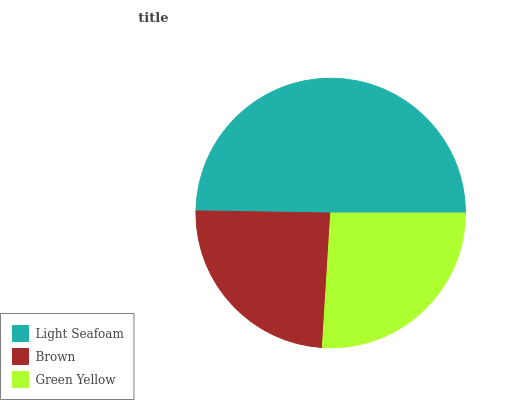Is Brown the minimum?
Answer yes or no. Yes. Is Light Seafoam the maximum?
Answer yes or no. Yes. Is Green Yellow the minimum?
Answer yes or no. No. Is Green Yellow the maximum?
Answer yes or no. No. Is Green Yellow greater than Brown?
Answer yes or no. Yes. Is Brown less than Green Yellow?
Answer yes or no. Yes. Is Brown greater than Green Yellow?
Answer yes or no. No. Is Green Yellow less than Brown?
Answer yes or no. No. Is Green Yellow the high median?
Answer yes or no. Yes. Is Green Yellow the low median?
Answer yes or no. Yes. Is Light Seafoam the high median?
Answer yes or no. No. Is Light Seafoam the low median?
Answer yes or no. No. 